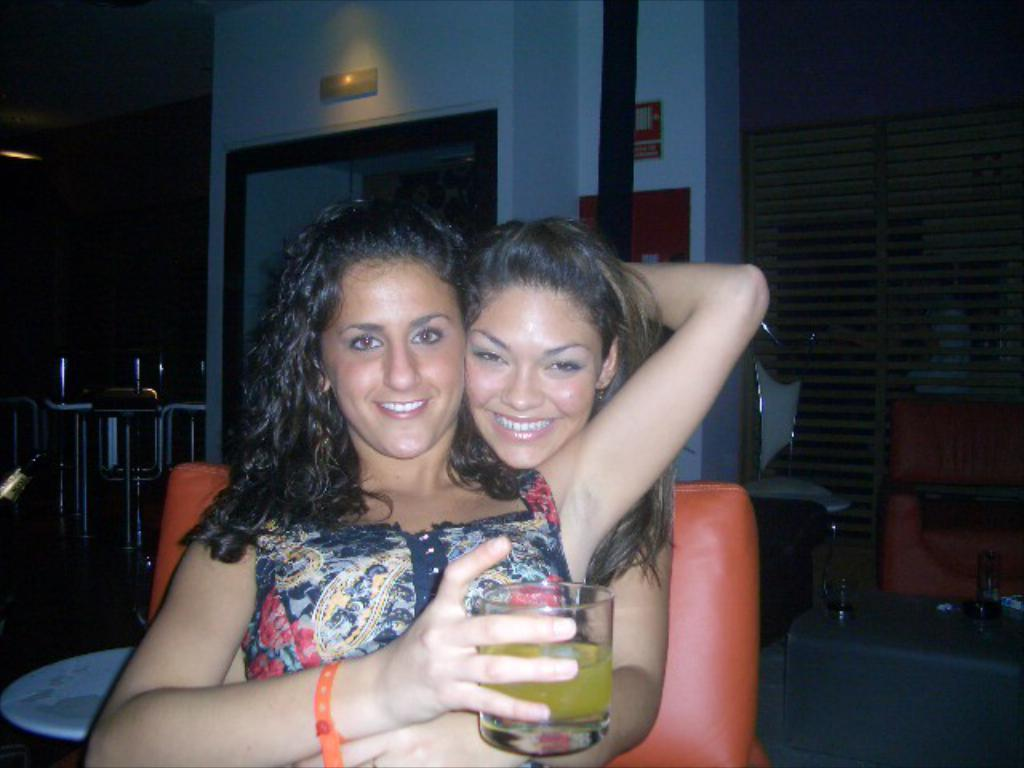How many women are in the image? There are two women in the image. What are the women doing in the image? The women are sitting on a chair and smiling. What is the woman in the front holding? The woman in the front is holding a glass. What can be seen in the background of the image? There is a wall and other objects visible in the background of the image. How many pigs are visible in the image? There are no pigs visible in the image. What is the woman in the back trying to get the attention of in the image? The image does not provide any information about the woman in the back trying to get the attention of anyone or anything. 